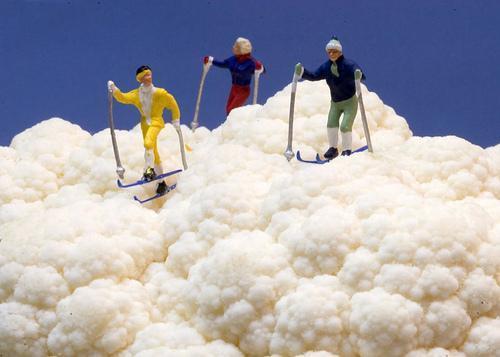How many figurines are in the picture?
Give a very brief answer. 3. 